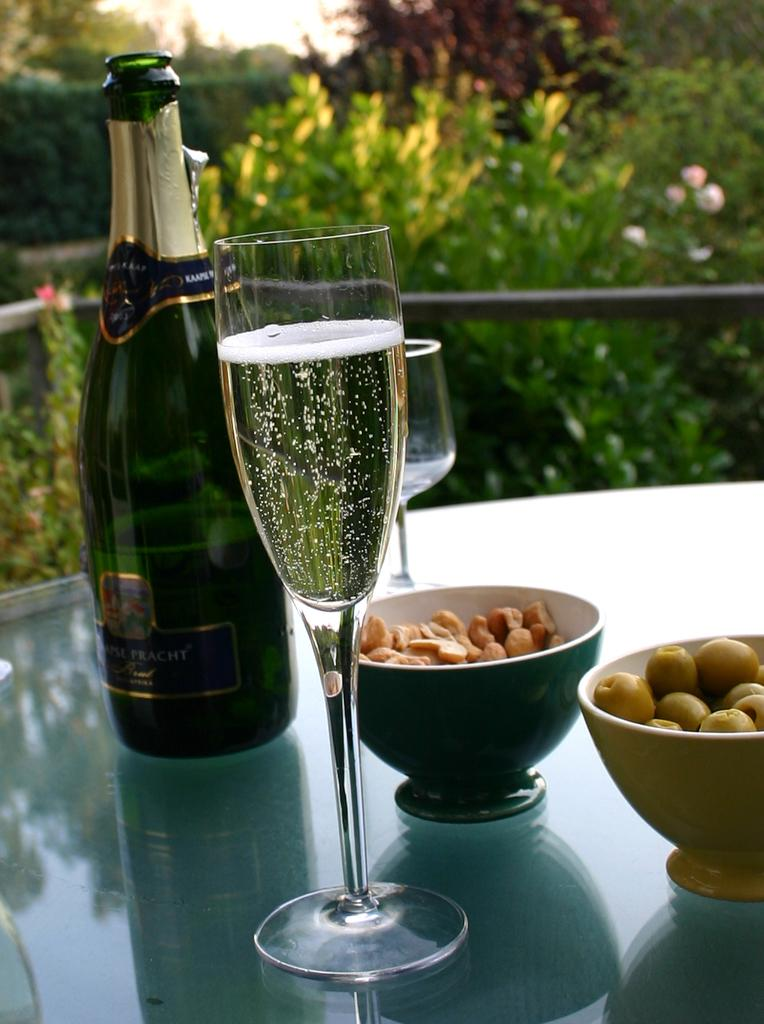What type of beverage container is on the table in the image? There is a wine bottle on the table. What is used for drinking the beverage in the image? There is a wine glass on the table. What type of snack is in a bowl on the table? There are cashew nuts in a bowl. What other type of snack is in a bowl on the table? There are olives in a bowl. What can be seen in the background of the image? There are trees visible in the background. What type of dolls are sitting on the table in the image? There are no dolls present in the image. What is the reason for the bag being placed on the table in the image? There is no bag present in the image, so it is not possible to determine the reason for its placement. 